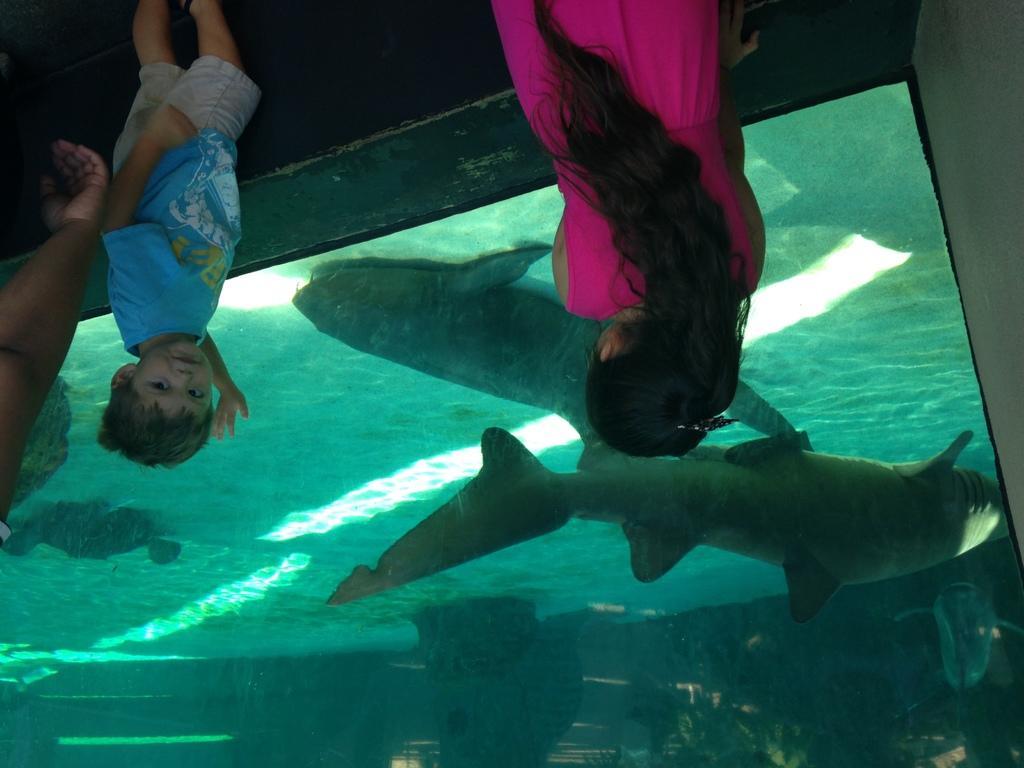Can you describe this image briefly? In this image we can see two kids wearing pink and blue color dress standing near the fish aquarium in which there are some fishes. 